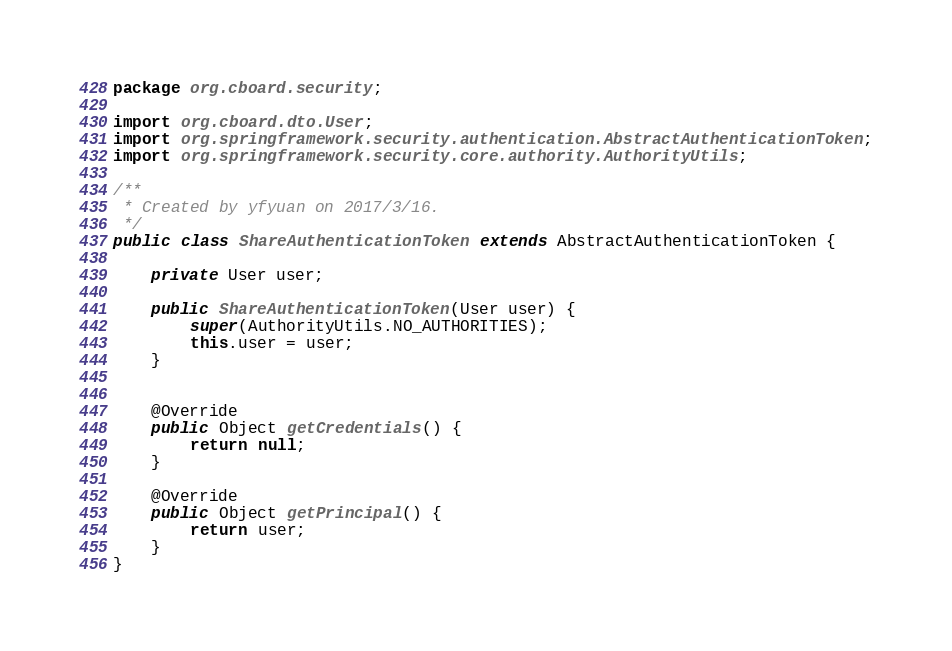Convert code to text. <code><loc_0><loc_0><loc_500><loc_500><_Java_>package org.cboard.security;

import org.cboard.dto.User;
import org.springframework.security.authentication.AbstractAuthenticationToken;
import org.springframework.security.core.authority.AuthorityUtils;

/**
 * Created by yfyuan on 2017/3/16.
 */
public class ShareAuthenticationToken extends AbstractAuthenticationToken {

    private User user;

    public ShareAuthenticationToken(User user) {
        super(AuthorityUtils.NO_AUTHORITIES);
        this.user = user;
    }


    @Override
    public Object getCredentials() {
        return null;
    }

    @Override
    public Object getPrincipal() {
        return user;
    }
}
</code> 